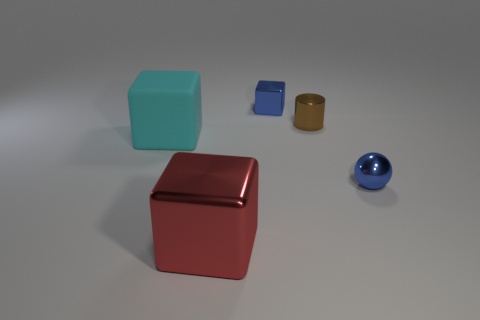Add 2 small gray balls. How many objects exist? 7 Subtract all blocks. How many objects are left? 2 Subtract all gray shiny objects. Subtract all tiny brown metallic cylinders. How many objects are left? 4 Add 5 cylinders. How many cylinders are left? 6 Add 3 large red metallic cubes. How many large red metallic cubes exist? 4 Subtract 1 brown cylinders. How many objects are left? 4 